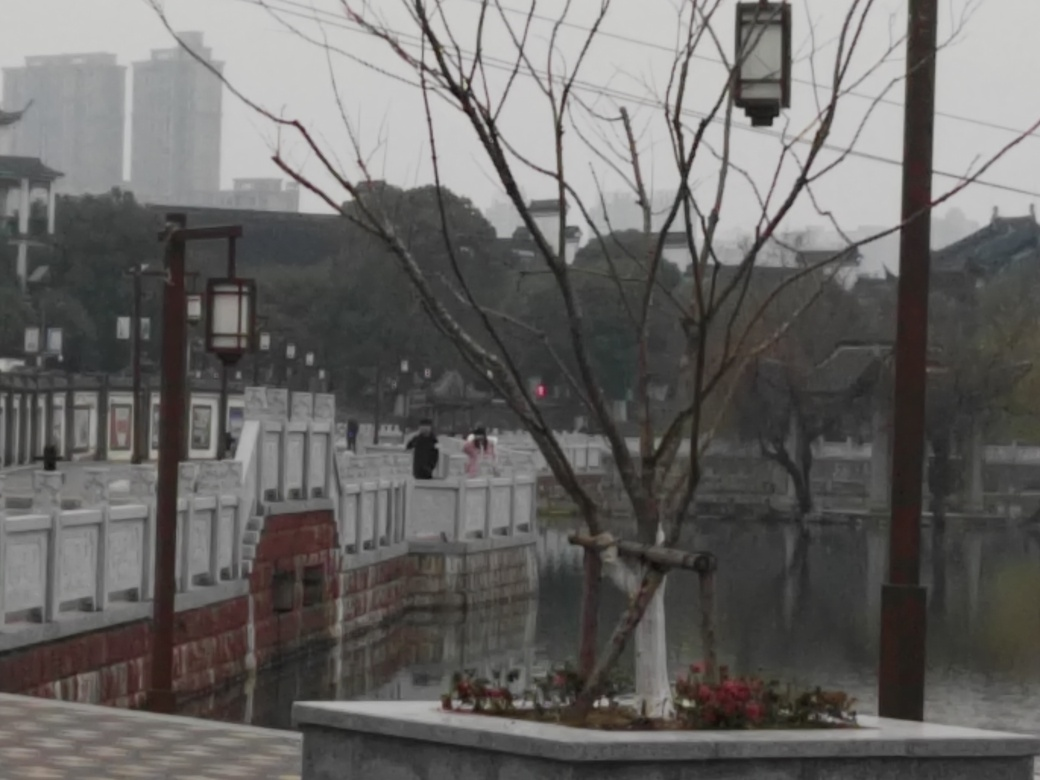What architectural style is present in the buildings we see in the background? The buildings in the background exhibit a traditional architectural style, likely from an East Asian cultural context. Their sweeping rooflines and distinct upturned eaves are characteristic of classical Chinese architecture, signifying a sense of historical continuity within the modern landscape. Could you tell me more about the bridge's features? Certainly. The bridge features a series of white balustrades lining the walkway, accented with red handrails that provide a splash of color. The path itself appears to be paved, suggesting a well-maintained public space. Additionally, the lampposts positioned at intervals add to the sense of order and safety. 